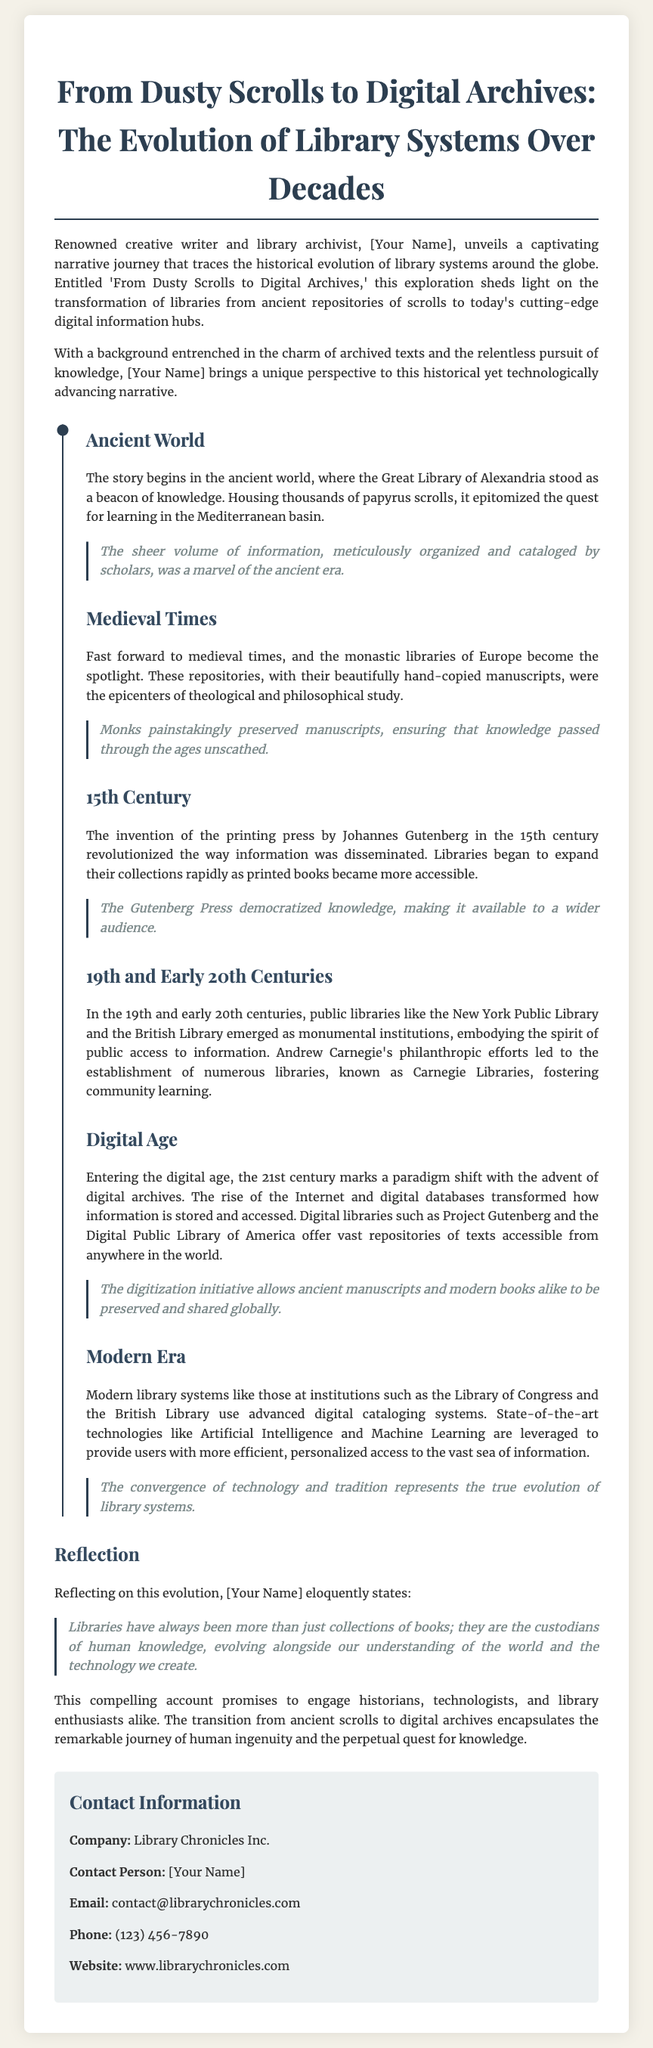What is the title of the press release? The title is a key piece of information and can be found at the beginning of the document.
Answer: From Dusty Scrolls to Digital Archives: The Evolution of Library Systems Over Decades Who is the author of the narrative journey? The author is mentioned in the context of the narrative journey presented in the press release.
Answer: [Your Name] What century did Johannes Gutenberg invent the printing press? The document specifies the time of the printing press invention, relevant to the evolution of libraries.
Answer: 15th Century Which library is highlighted as a monument in the 19th and early 20th centuries? This library represents a pivotal institution in the evolution of library systems mentioned in the document.
Answer: New York Public Library What term describes modern library systems' technology use? The document mentions advanced technologies in modern library systems, highlighting their significance.
Answer: Artificial Intelligence and Machine Learning In which library system is the quote about custodians of human knowledge found? This quote is part of a reflection on the evolution of libraries, key to understanding its theme.
Answer: Reflection What is the primary focus of the press release? The main subject or theme of the press release can help in understanding its purpose.
Answer: Evolution of library systems What significant library development occurred with the advent of the digital age? The digital age brought substantial changes in how libraries operate, which is a focal point in the document.
Answer: Digital archives What company is mentioned in the contact information section? The contact information section lists the organization related to the press release.
Answer: Library Chronicles Inc 